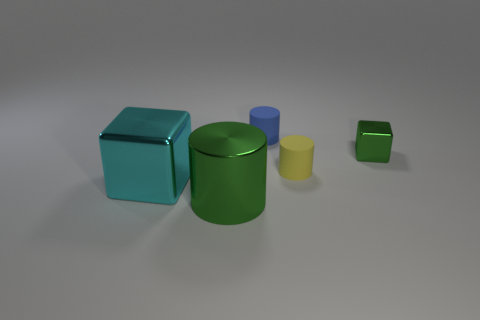What size is the thing that is the same color as the large metallic cylinder?
Your answer should be compact. Small. Is the number of green blocks that are in front of the tiny blue rubber object greater than the number of purple rubber blocks?
Offer a very short reply. Yes. There is a blue object; is it the same shape as the metallic thing that is to the left of the large green cylinder?
Ensure brevity in your answer.  No. What number of other yellow cylinders have the same size as the metallic cylinder?
Ensure brevity in your answer.  0. There is a metallic cube on the left side of the rubber cylinder on the left side of the small yellow rubber thing; what number of large objects are to the right of it?
Your response must be concise. 1. Are there an equal number of small blocks that are behind the yellow rubber cylinder and yellow cylinders in front of the big green shiny thing?
Provide a succinct answer. No. How many cyan objects are the same shape as the tiny green object?
Offer a very short reply. 1. Is there another yellow cylinder that has the same material as the small yellow cylinder?
Provide a succinct answer. No. There is a tiny metallic thing that is the same color as the metallic cylinder; what is its shape?
Give a very brief answer. Cube. How many blue cylinders are there?
Keep it short and to the point. 1. 